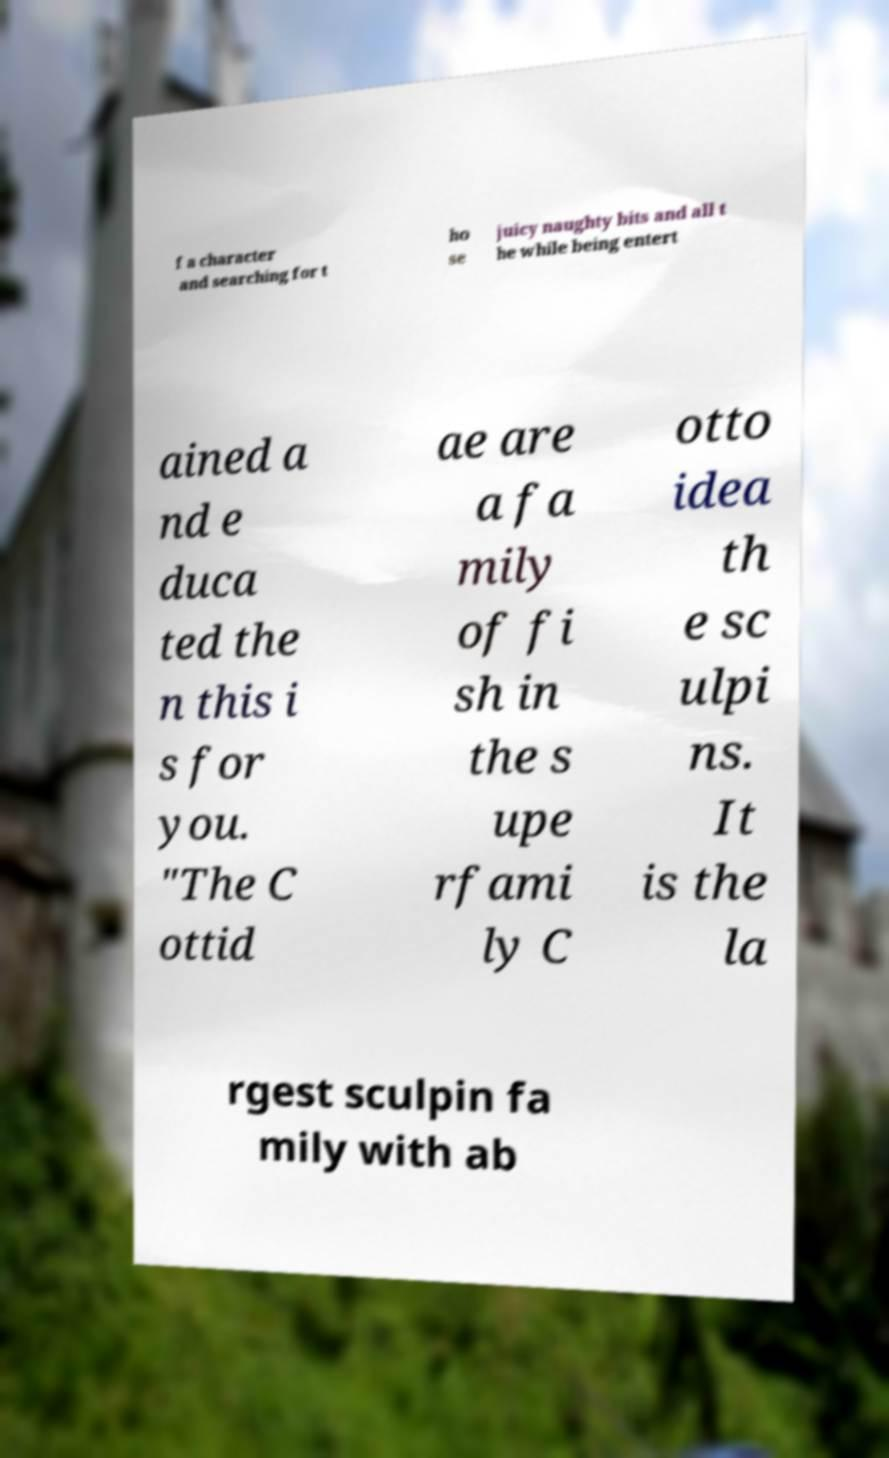I need the written content from this picture converted into text. Can you do that? f a character and searching for t ho se juicy naughty bits and all t he while being entert ained a nd e duca ted the n this i s for you. "The C ottid ae are a fa mily of fi sh in the s upe rfami ly C otto idea th e sc ulpi ns. It is the la rgest sculpin fa mily with ab 